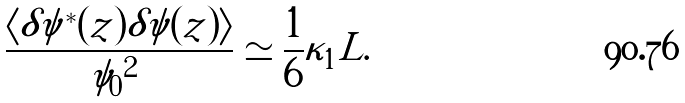Convert formula to latex. <formula><loc_0><loc_0><loc_500><loc_500>\frac { \langle \delta \psi ^ { * } ( z ) \delta \psi ( z ) \rangle } { | \psi _ { 0 } | ^ { 2 } } \simeq \frac { 1 } { 6 } \kappa _ { 1 } L .</formula> 